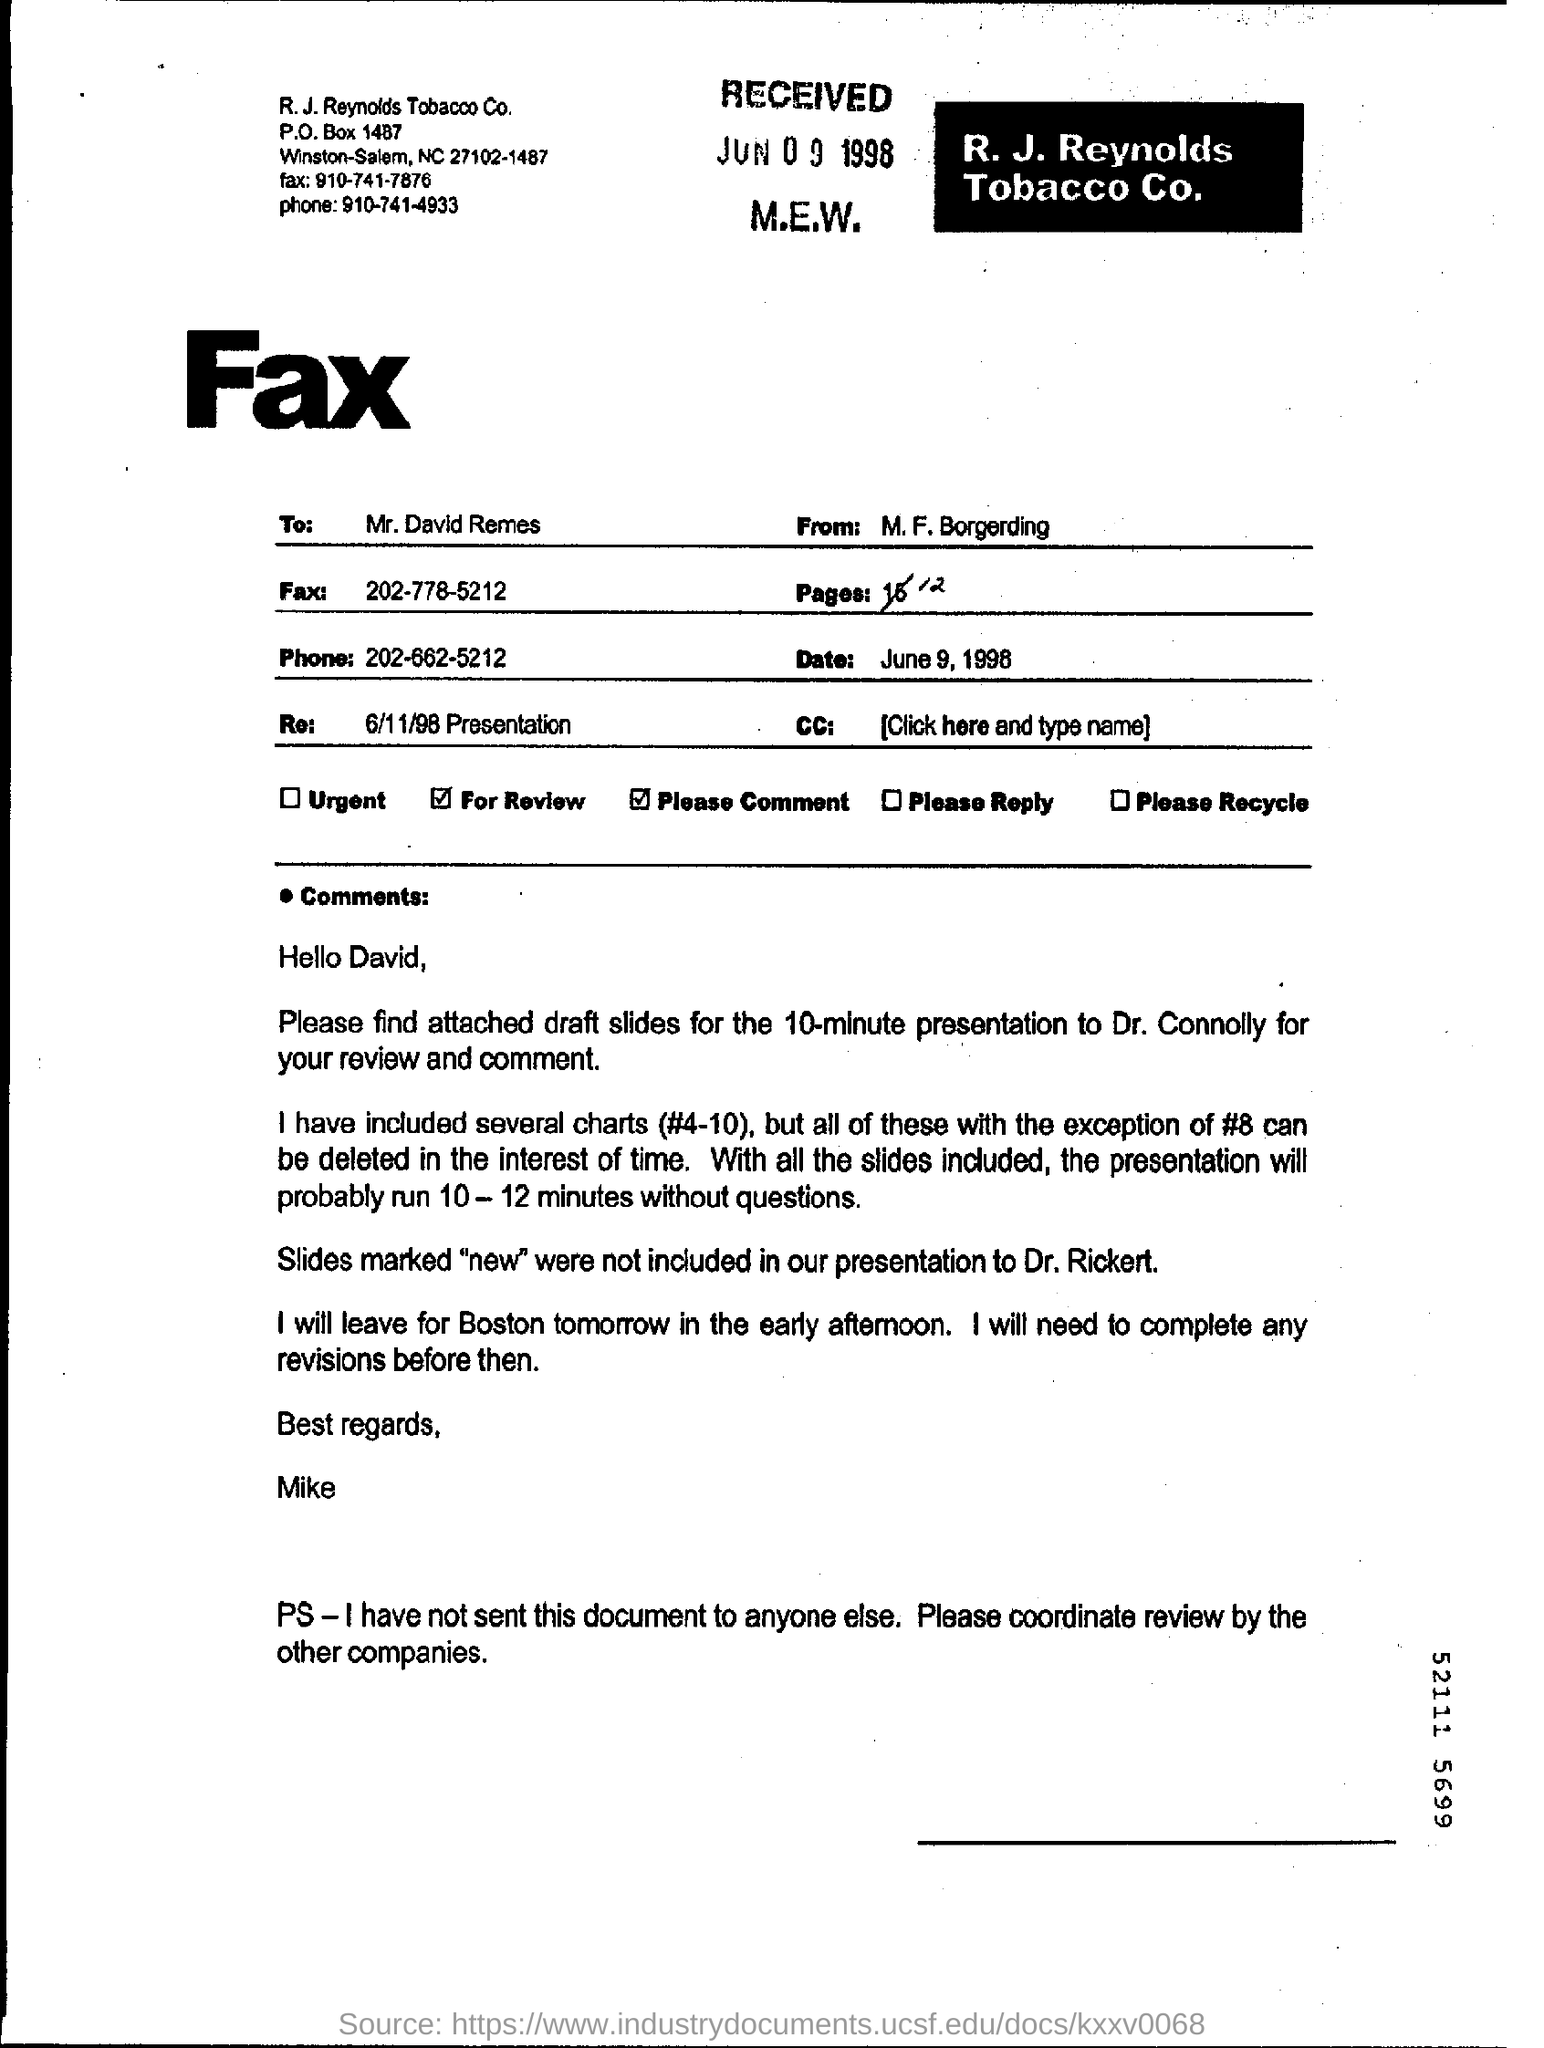What is written in big bold letters?
Your answer should be very brief. Fax. To whom is this document addressed?
Provide a short and direct response. Mr. David Remes. By which name is the receiver of this document addressed in short?
Provide a short and direct response. David. 